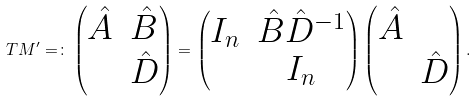<formula> <loc_0><loc_0><loc_500><loc_500>T M ^ { \prime } = \colon \left ( \begin{matrix} \hat { A } & \hat { B } \\ & \hat { D } \end{matrix} \right ) = \left ( \begin{matrix} I _ { n } & \hat { B } { \hat { D } } ^ { - 1 } \\ & I _ { n } \end{matrix} \right ) \left ( \begin{matrix} \hat { A } & \\ & \hat { D } \end{matrix} \right ) .</formula> 